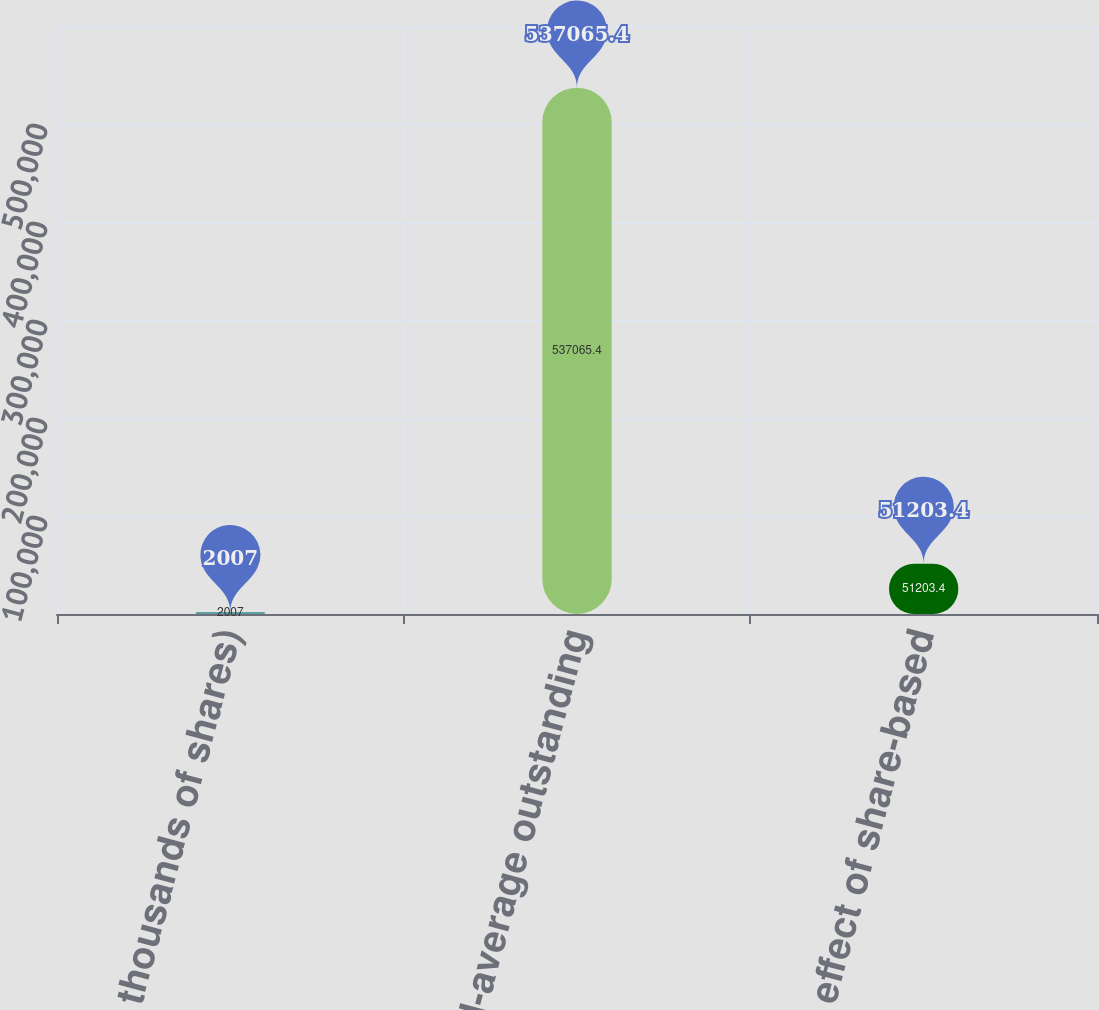<chart> <loc_0><loc_0><loc_500><loc_500><bar_chart><fcel>(In thousands of shares)<fcel>Weighted-average outstanding<fcel>Dilutive effect of share-based<nl><fcel>2007<fcel>537065<fcel>51203.4<nl></chart> 